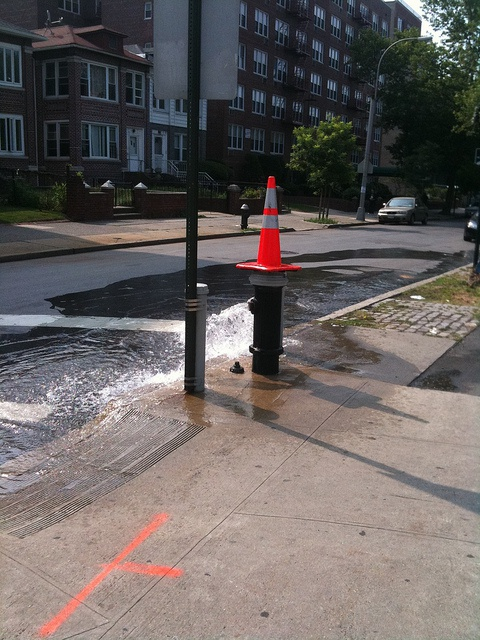Describe the objects in this image and their specific colors. I can see fire hydrant in black and gray tones, car in black, darkgray, and gray tones, car in black, gray, and lightgray tones, and fire hydrant in black, gray, and darkgray tones in this image. 